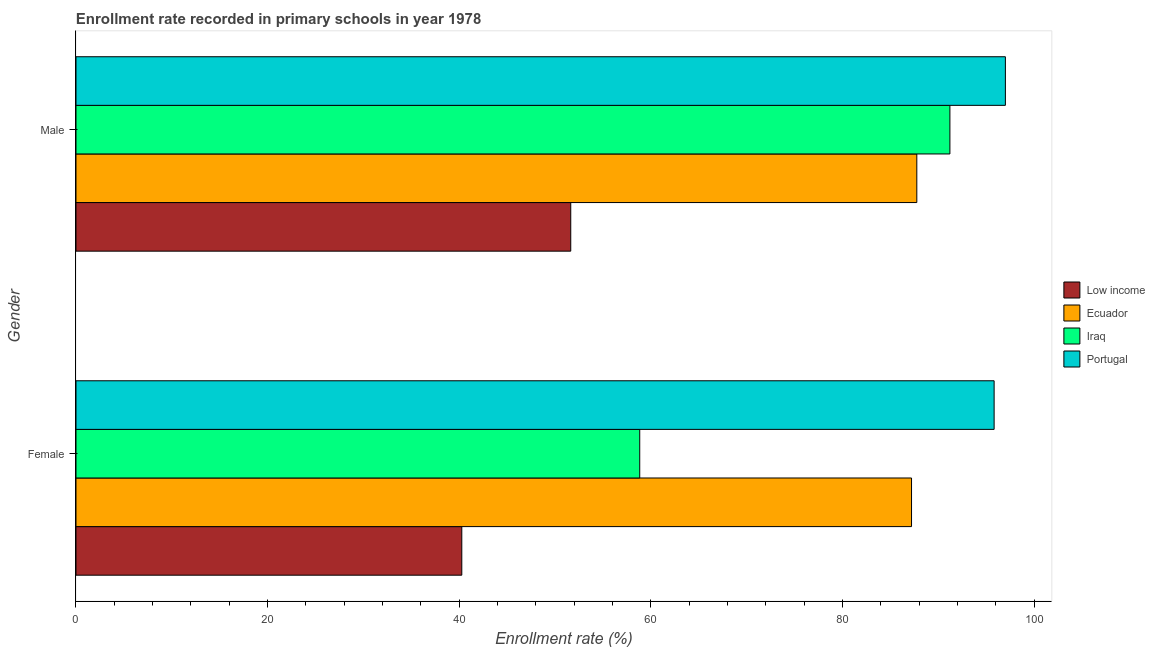How many different coloured bars are there?
Make the answer very short. 4. Are the number of bars on each tick of the Y-axis equal?
Your answer should be very brief. Yes. How many bars are there on the 2nd tick from the top?
Keep it short and to the point. 4. How many bars are there on the 1st tick from the bottom?
Make the answer very short. 4. What is the enrollment rate of male students in Iraq?
Ensure brevity in your answer.  91.2. Across all countries, what is the maximum enrollment rate of female students?
Your response must be concise. 95.81. Across all countries, what is the minimum enrollment rate of female students?
Your answer should be very brief. 40.26. In which country was the enrollment rate of female students maximum?
Your response must be concise. Portugal. What is the total enrollment rate of male students in the graph?
Offer a very short reply. 327.55. What is the difference between the enrollment rate of female students in Ecuador and that in Iraq?
Your answer should be compact. 28.36. What is the difference between the enrollment rate of male students in Low income and the enrollment rate of female students in Portugal?
Offer a very short reply. -44.18. What is the average enrollment rate of male students per country?
Your response must be concise. 81.89. What is the difference between the enrollment rate of male students and enrollment rate of female students in Portugal?
Give a very brief answer. 1.18. What is the ratio of the enrollment rate of male students in Iraq to that in Ecuador?
Your answer should be very brief. 1.04. In how many countries, is the enrollment rate of male students greater than the average enrollment rate of male students taken over all countries?
Ensure brevity in your answer.  3. What does the 3rd bar from the top in Female represents?
Your answer should be compact. Ecuador. What does the 2nd bar from the bottom in Female represents?
Make the answer very short. Ecuador. How many bars are there?
Give a very brief answer. 8. How many countries are there in the graph?
Your response must be concise. 4. Are the values on the major ticks of X-axis written in scientific E-notation?
Ensure brevity in your answer.  No. Does the graph contain grids?
Make the answer very short. No. Where does the legend appear in the graph?
Provide a short and direct response. Center right. What is the title of the graph?
Your response must be concise. Enrollment rate recorded in primary schools in year 1978. Does "Cameroon" appear as one of the legend labels in the graph?
Offer a very short reply. No. What is the label or title of the X-axis?
Your response must be concise. Enrollment rate (%). What is the Enrollment rate (%) in Low income in Female?
Offer a very short reply. 40.26. What is the Enrollment rate (%) in Ecuador in Female?
Your response must be concise. 87.19. What is the Enrollment rate (%) of Iraq in Female?
Offer a very short reply. 58.83. What is the Enrollment rate (%) in Portugal in Female?
Provide a short and direct response. 95.81. What is the Enrollment rate (%) in Low income in Male?
Make the answer very short. 51.63. What is the Enrollment rate (%) of Ecuador in Male?
Offer a terse response. 87.74. What is the Enrollment rate (%) of Iraq in Male?
Give a very brief answer. 91.2. What is the Enrollment rate (%) of Portugal in Male?
Provide a short and direct response. 96.99. Across all Gender, what is the maximum Enrollment rate (%) in Low income?
Offer a terse response. 51.63. Across all Gender, what is the maximum Enrollment rate (%) in Ecuador?
Provide a short and direct response. 87.74. Across all Gender, what is the maximum Enrollment rate (%) of Iraq?
Give a very brief answer. 91.2. Across all Gender, what is the maximum Enrollment rate (%) of Portugal?
Ensure brevity in your answer.  96.99. Across all Gender, what is the minimum Enrollment rate (%) in Low income?
Offer a terse response. 40.26. Across all Gender, what is the minimum Enrollment rate (%) in Ecuador?
Your answer should be compact. 87.19. Across all Gender, what is the minimum Enrollment rate (%) of Iraq?
Make the answer very short. 58.83. Across all Gender, what is the minimum Enrollment rate (%) of Portugal?
Ensure brevity in your answer.  95.81. What is the total Enrollment rate (%) in Low income in the graph?
Your answer should be very brief. 91.89. What is the total Enrollment rate (%) in Ecuador in the graph?
Your answer should be compact. 174.93. What is the total Enrollment rate (%) of Iraq in the graph?
Your answer should be compact. 150.02. What is the total Enrollment rate (%) of Portugal in the graph?
Provide a succinct answer. 192.8. What is the difference between the Enrollment rate (%) in Low income in Female and that in Male?
Ensure brevity in your answer.  -11.37. What is the difference between the Enrollment rate (%) of Ecuador in Female and that in Male?
Ensure brevity in your answer.  -0.55. What is the difference between the Enrollment rate (%) of Iraq in Female and that in Male?
Provide a succinct answer. -32.37. What is the difference between the Enrollment rate (%) of Portugal in Female and that in Male?
Make the answer very short. -1.18. What is the difference between the Enrollment rate (%) of Low income in Female and the Enrollment rate (%) of Ecuador in Male?
Your answer should be compact. -47.48. What is the difference between the Enrollment rate (%) in Low income in Female and the Enrollment rate (%) in Iraq in Male?
Provide a short and direct response. -50.94. What is the difference between the Enrollment rate (%) in Low income in Female and the Enrollment rate (%) in Portugal in Male?
Your answer should be compact. -56.73. What is the difference between the Enrollment rate (%) of Ecuador in Female and the Enrollment rate (%) of Iraq in Male?
Give a very brief answer. -4.01. What is the difference between the Enrollment rate (%) in Ecuador in Female and the Enrollment rate (%) in Portugal in Male?
Offer a terse response. -9.8. What is the difference between the Enrollment rate (%) in Iraq in Female and the Enrollment rate (%) in Portugal in Male?
Your response must be concise. -38.16. What is the average Enrollment rate (%) in Low income per Gender?
Offer a very short reply. 45.94. What is the average Enrollment rate (%) of Ecuador per Gender?
Your response must be concise. 87.47. What is the average Enrollment rate (%) in Iraq per Gender?
Give a very brief answer. 75.01. What is the average Enrollment rate (%) in Portugal per Gender?
Your response must be concise. 96.4. What is the difference between the Enrollment rate (%) of Low income and Enrollment rate (%) of Ecuador in Female?
Your response must be concise. -46.93. What is the difference between the Enrollment rate (%) of Low income and Enrollment rate (%) of Iraq in Female?
Ensure brevity in your answer.  -18.57. What is the difference between the Enrollment rate (%) of Low income and Enrollment rate (%) of Portugal in Female?
Provide a succinct answer. -55.55. What is the difference between the Enrollment rate (%) of Ecuador and Enrollment rate (%) of Iraq in Female?
Your answer should be very brief. 28.36. What is the difference between the Enrollment rate (%) in Ecuador and Enrollment rate (%) in Portugal in Female?
Provide a short and direct response. -8.62. What is the difference between the Enrollment rate (%) in Iraq and Enrollment rate (%) in Portugal in Female?
Ensure brevity in your answer.  -36.98. What is the difference between the Enrollment rate (%) in Low income and Enrollment rate (%) in Ecuador in Male?
Give a very brief answer. -36.11. What is the difference between the Enrollment rate (%) of Low income and Enrollment rate (%) of Iraq in Male?
Keep it short and to the point. -39.57. What is the difference between the Enrollment rate (%) in Low income and Enrollment rate (%) in Portugal in Male?
Provide a short and direct response. -45.36. What is the difference between the Enrollment rate (%) in Ecuador and Enrollment rate (%) in Iraq in Male?
Provide a succinct answer. -3.45. What is the difference between the Enrollment rate (%) of Ecuador and Enrollment rate (%) of Portugal in Male?
Keep it short and to the point. -9.24. What is the difference between the Enrollment rate (%) of Iraq and Enrollment rate (%) of Portugal in Male?
Your response must be concise. -5.79. What is the ratio of the Enrollment rate (%) in Low income in Female to that in Male?
Your answer should be compact. 0.78. What is the ratio of the Enrollment rate (%) of Ecuador in Female to that in Male?
Your answer should be compact. 0.99. What is the ratio of the Enrollment rate (%) of Iraq in Female to that in Male?
Your response must be concise. 0.65. What is the ratio of the Enrollment rate (%) in Portugal in Female to that in Male?
Provide a short and direct response. 0.99. What is the difference between the highest and the second highest Enrollment rate (%) in Low income?
Your answer should be very brief. 11.37. What is the difference between the highest and the second highest Enrollment rate (%) in Ecuador?
Offer a terse response. 0.55. What is the difference between the highest and the second highest Enrollment rate (%) of Iraq?
Your answer should be very brief. 32.37. What is the difference between the highest and the second highest Enrollment rate (%) in Portugal?
Keep it short and to the point. 1.18. What is the difference between the highest and the lowest Enrollment rate (%) of Low income?
Offer a terse response. 11.37. What is the difference between the highest and the lowest Enrollment rate (%) in Ecuador?
Offer a terse response. 0.55. What is the difference between the highest and the lowest Enrollment rate (%) of Iraq?
Offer a terse response. 32.37. What is the difference between the highest and the lowest Enrollment rate (%) of Portugal?
Keep it short and to the point. 1.18. 